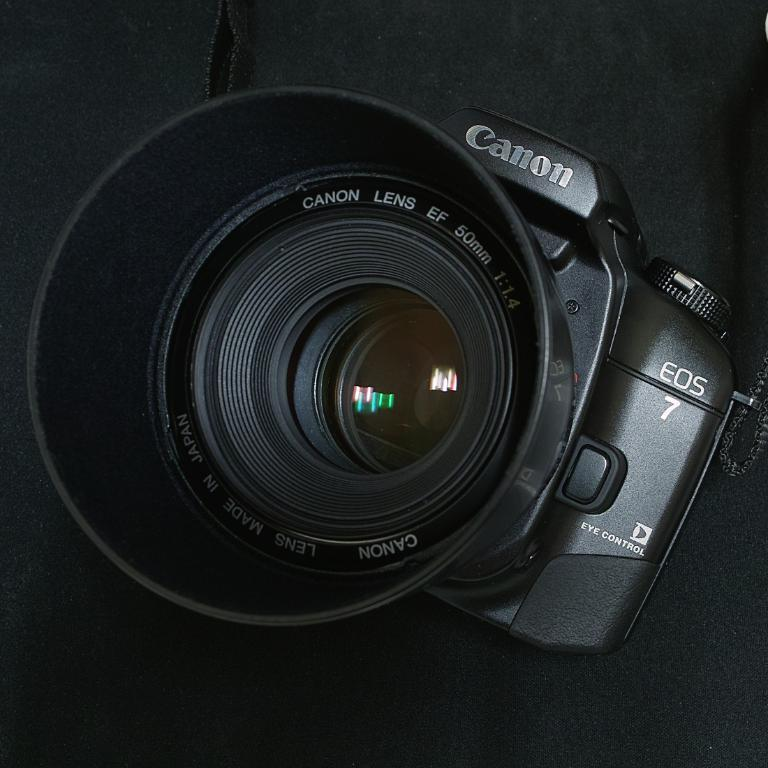What object is the main focus of the image? There is a camera in the image. What type of pencil is being used to draw the camera in the image? There is no pencil or drawing present in the image; it is a photograph of a camera. What flavor of pie is depicted next to the camera in the image? There is no pie present in the image; it only features a camera. 